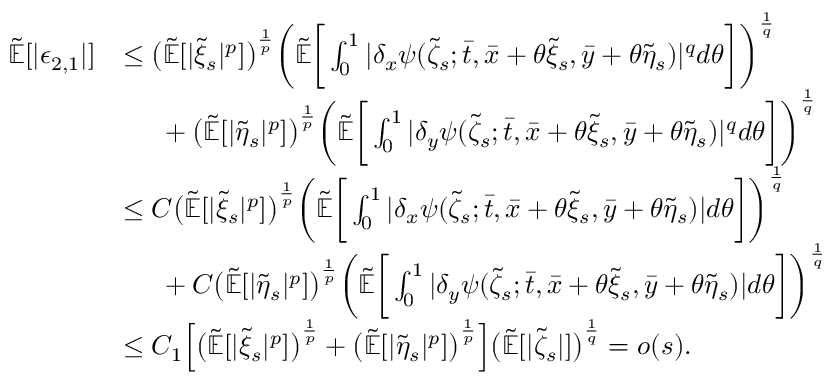Convert formula to latex. <formula><loc_0><loc_0><loc_500><loc_500>\begin{array} { r l } { \mathbb { \tilde { E } } [ | \epsilon _ { 2 , 1 } | ] } & { \leq \left ( \mathbb { \tilde { E } } [ | \tilde { \xi } _ { s } | ^ { p } ] \right ) ^ { \frac { 1 } { p } } \left ( \mathbb { \tilde { E } } \left [ \int _ { 0 } ^ { 1 } | \delta _ { x } \psi ( \tilde { \zeta } _ { s } ; \bar { t } , \bar { x } + \theta \tilde { \xi } _ { s } , \bar { y } + \theta \tilde { \eta } _ { s } ) | ^ { q } d \theta \right ] \right ) ^ { \frac { 1 } { q } } } \\ & { \ \ + \left ( \mathbb { \tilde { E } } [ | \tilde { \eta } _ { s } | ^ { p } ] \right ) ^ { \frac { 1 } { p } } \left ( \mathbb { \tilde { E } } \left [ \int _ { 0 } ^ { 1 } | \delta _ { y } \psi ( \tilde { \zeta } _ { s } ; \bar { t } , \bar { x } + \theta \tilde { \xi } _ { s } , \bar { y } + \theta \tilde { \eta } _ { s } ) | ^ { q } d \theta \right ] \right ) ^ { \frac { 1 } { q } } } \\ & { \leq C \left ( \mathbb { \tilde { E } } [ | \tilde { \xi } _ { s } | ^ { p } ] \right ) ^ { \frac { 1 } { p } } \left ( \mathbb { \tilde { E } } \left [ \int _ { 0 } ^ { 1 } | \delta _ { x } \psi ( \tilde { \zeta } _ { s } ; \bar { t } , \bar { x } + \theta \tilde { \xi } _ { s } , \bar { y } + \theta \tilde { \eta } _ { s } ) | d \theta \right ] \right ) ^ { \frac { 1 } { q } } } \\ & { \ \ + C \left ( \mathbb { \tilde { E } } [ | \tilde { \eta } _ { s } | ^ { p } ] \right ) ^ { \frac { 1 } { p } } \left ( \mathbb { \tilde { E } } \left [ \int _ { 0 } ^ { 1 } | \delta _ { y } \psi ( \tilde { \zeta } _ { s } ; \bar { t } , \bar { x } + \theta \tilde { \xi } _ { s } , \bar { y } + \theta \tilde { \eta } _ { s } ) | d \theta \right ] \right ) ^ { \frac { 1 } { q } } } \\ & { \leq C _ { 1 } \left [ \left ( \mathbb { \tilde { E } } [ | \tilde { \xi } _ { s } | ^ { p } ] \right ) ^ { \frac { 1 } { p } } + \left ( \mathbb { \tilde { E } } [ | \tilde { \eta } _ { s } | ^ { p } ] \right ) ^ { \frac { 1 } { p } } \right ] \left ( \mathbb { \tilde { E } } [ | \tilde { \zeta } _ { s } | ] \right ) ^ { \frac { 1 } { q } } = o ( s ) . } \end{array}</formula> 